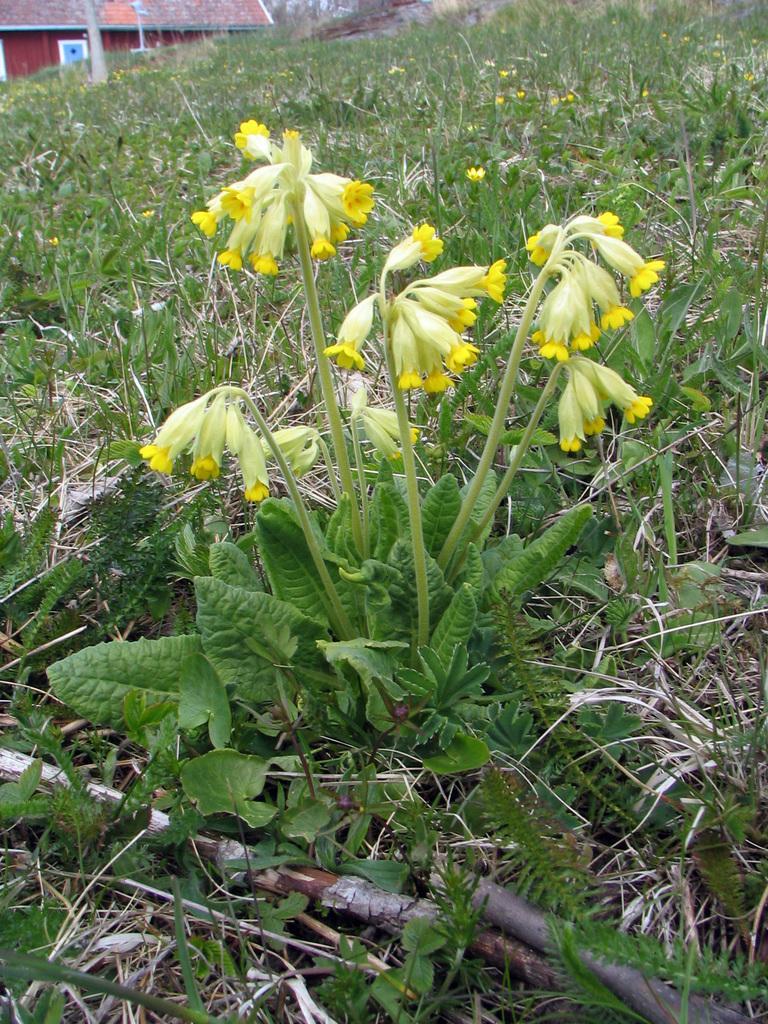Can you describe this image briefly? In this picture there is greenery around the area of the image and there is a house at the top side of the image. 